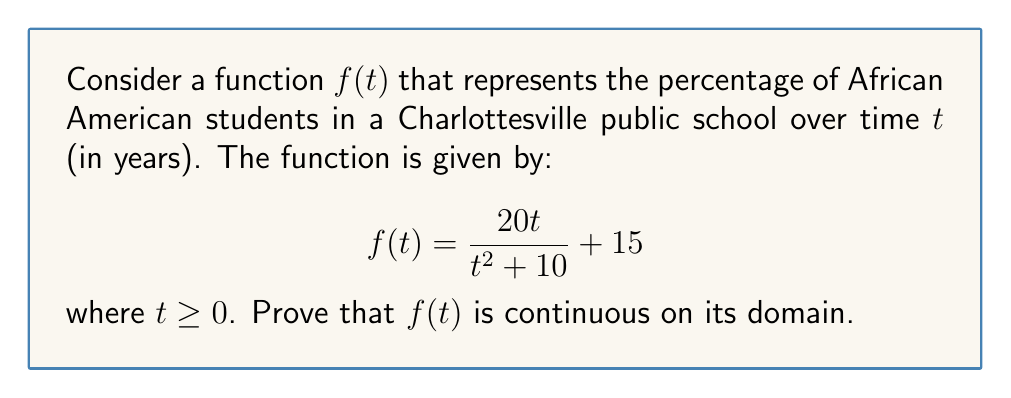Teach me how to tackle this problem. To prove that $f(t)$ is continuous on its domain, we need to show that it is continuous for all $t \geq 0$. We can do this by demonstrating that $f(t)$ is a rational function with a non-zero denominator for all $t$ in its domain.

1. First, let's examine the domain of $f(t)$:
   The function is defined for all $t \geq 0$ where the denominator is not zero.
   The denominator is $t^2 + 10$, which is always positive for real $t$.
   Therefore, the domain is indeed all $t \geq 0$.

2. Now, let's consider the continuity of $f(t)$:
   $f(t)$ is the sum of two terms: $\frac{20t}{t^2 + 10}$ and $15$.

3. The constant term 15 is continuous for all real numbers.

4. For the fraction $\frac{20t}{t^2 + 10}$:
   - The numerator $20t$ is a polynomial, which is continuous for all real numbers.
   - The denominator $t^2 + 10$ is also a polynomial, continuous for all real numbers.
   - The denominator is never zero on the domain (as shown in step 1).
   - The quotient of two continuous functions is continuous wherever the denominator is not zero.

5. The sum of two continuous functions is continuous.

Therefore, $f(t)$ is continuous for all $t \geq 0$, which is its entire domain.

To further illustrate this, we can also show that the limit of $f(t)$ as $t$ approaches any point $a$ in its domain equals $f(a)$:

$$\lim_{t \to a} f(t) = \lim_{t \to a} \left(\frac{20t}{t^2 + 10} + 15\right) = \frac{20a}{a^2 + 10} + 15 = f(a)$$

This holds for all $a \geq 0$, confirming the continuity of $f(t)$ on its domain.
Answer: $f(t)$ is continuous for all $t \geq 0$. 